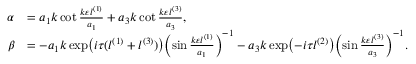Convert formula to latex. <formula><loc_0><loc_0><loc_500><loc_500>\begin{array} { r l } { \alpha } & { = a _ { 1 } k \cot \frac { k \varepsilon l ^ { ( 1 ) } } { a _ { 1 } } + a _ { 3 } k \cot \frac { k \varepsilon l ^ { ( 3 ) } } { a _ { 3 } } , } \\ { \beta } & { = - a _ { 1 } k \exp \left ( i \tau ( l ^ { ( 1 ) } + l ^ { ( 3 ) } ) \right ) \left ( \sin \frac { k \varepsilon l ^ { ( 1 ) } } { a _ { 1 } } \right ) ^ { - 1 } - a _ { 3 } k \exp \left ( - i \tau l ^ { ( 2 ) } \right ) \left ( \sin \frac { k \varepsilon l ^ { ( 3 ) } } { a _ { 3 } } \right ) ^ { - 1 } . } \end{array}</formula> 